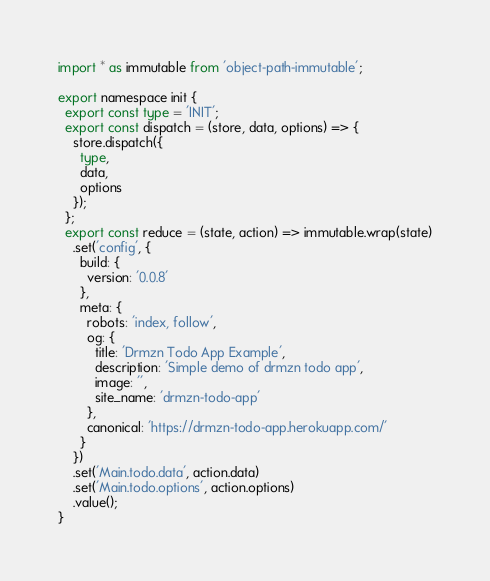Convert code to text. <code><loc_0><loc_0><loc_500><loc_500><_TypeScript_>import * as immutable from 'object-path-immutable';

export namespace init {
  export const type = 'INIT';
  export const dispatch = (store, data, options) => {
    store.dispatch({
      type,
      data,
      options
    });
  };
  export const reduce = (state, action) => immutable.wrap(state)
    .set('config', {
      build: {
        version: '0.0.8'
      },
      meta: {
        robots: 'index, follow',
        og: {
          title: 'Drmzn Todo App Example',
          description: 'Simple demo of drmzn todo app',
          image: '',
          site_name: 'drmzn-todo-app'
        },
        canonical: 'https://drmzn-todo-app.herokuapp.com/'
      }
    })
    .set('Main.todo.data', action.data)
    .set('Main.todo.options', action.options)
    .value();
}
</code> 